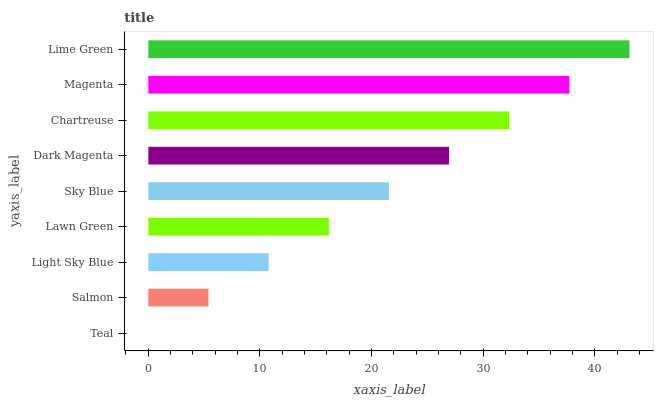Is Teal the minimum?
Answer yes or no. Yes. Is Lime Green the maximum?
Answer yes or no. Yes. Is Salmon the minimum?
Answer yes or no. No. Is Salmon the maximum?
Answer yes or no. No. Is Salmon greater than Teal?
Answer yes or no. Yes. Is Teal less than Salmon?
Answer yes or no. Yes. Is Teal greater than Salmon?
Answer yes or no. No. Is Salmon less than Teal?
Answer yes or no. No. Is Sky Blue the high median?
Answer yes or no. Yes. Is Sky Blue the low median?
Answer yes or no. Yes. Is Lime Green the high median?
Answer yes or no. No. Is Lawn Green the low median?
Answer yes or no. No. 